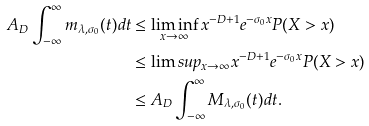<formula> <loc_0><loc_0><loc_500><loc_500>A _ { D } \int _ { - \infty } ^ { \infty } m _ { \lambda , \sigma _ { 0 } } ( t ) d t & \leq \liminf _ { x \to \infty } x ^ { - D + 1 } e ^ { - \sigma _ { 0 } x } P ( X > x ) \\ & \leq \lim s u p _ { x \to \infty } x ^ { - D + 1 } e ^ { - \sigma _ { 0 } x } P ( X > x ) \\ & \leq A _ { D } \int _ { - \infty } ^ { \infty } M _ { \lambda , \sigma _ { 0 } } ( t ) d t .</formula> 